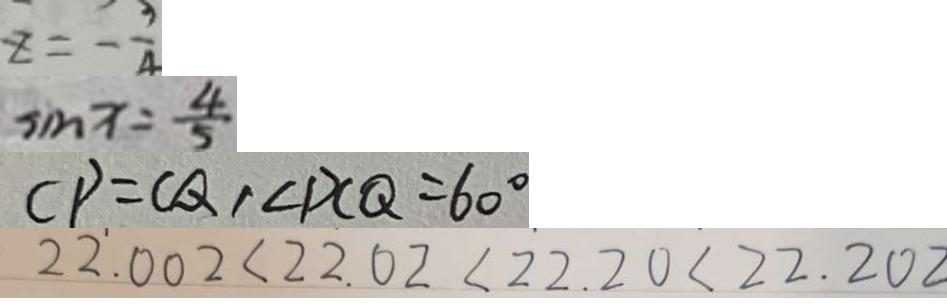Convert formula to latex. <formula><loc_0><loc_0><loc_500><loc_500>z = - \frac { 3 } { 4 } 
 \sin x = \frac { 4 } { 5 } 
 C P = C Q , \angle D C Q = 6 0 ^ { \circ } 
 2 2 . 0 0 2 < 2 2 . 0 2 < 2 2 . 2 0 < 2 2 . 2 0 2</formula> 